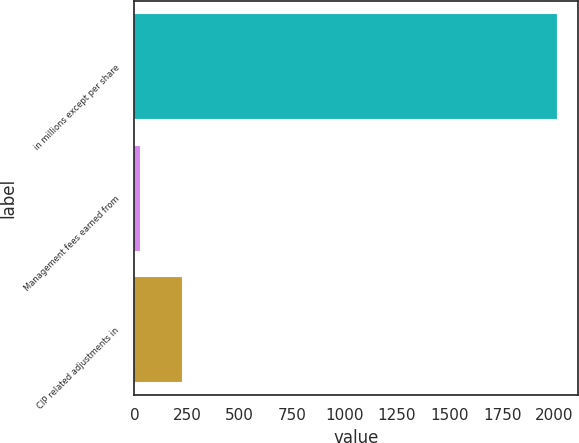Convert chart. <chart><loc_0><loc_0><loc_500><loc_500><bar_chart><fcel>in millions except per share<fcel>Management fees earned from<fcel>CIP related adjustments in<nl><fcel>2013<fcel>27<fcel>225.6<nl></chart> 